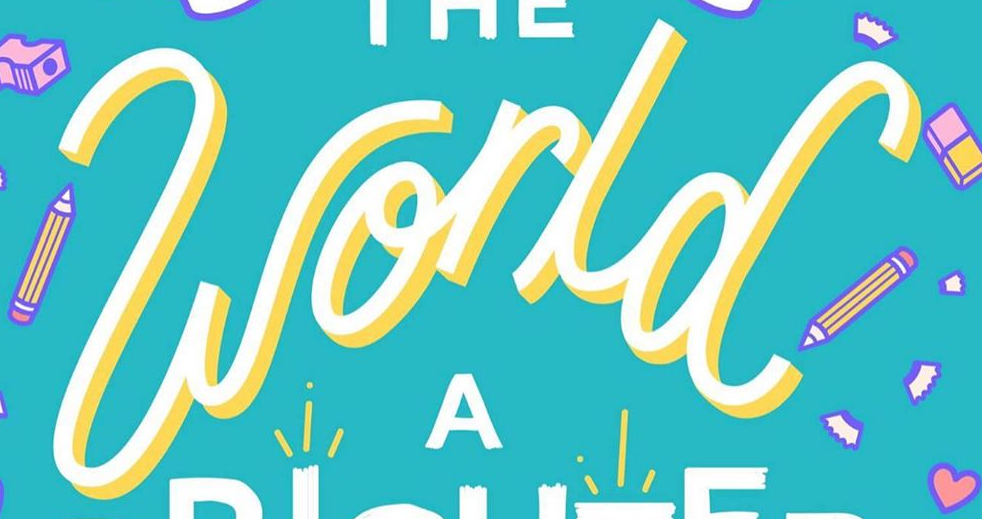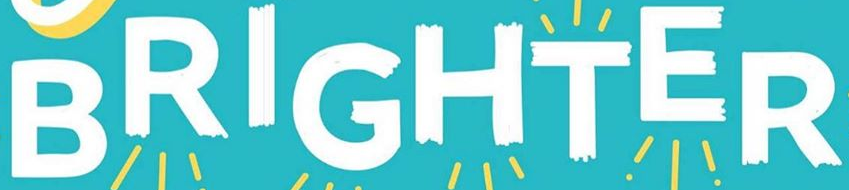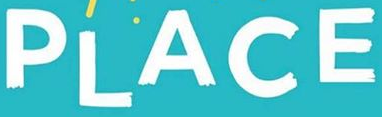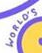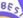What words are shown in these images in order, separated by a semicolon? world; BRIGHTER; PLACE; WORLO'S; BES 